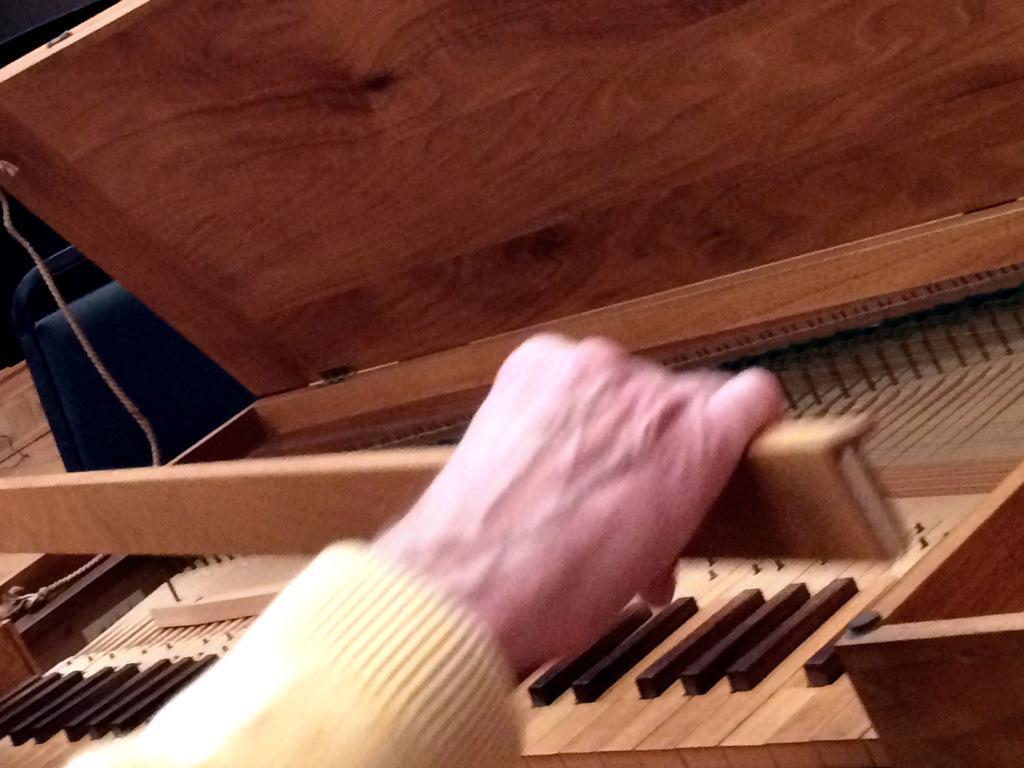Could you give a brief overview of what you see in this image? This picture shows a man holding a stick and we see a piano 